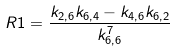<formula> <loc_0><loc_0><loc_500><loc_500>R 1 = \frac { k _ { 2 , 6 } k _ { 6 , 4 } - k _ { 4 , 6 } k _ { 6 , 2 } } { k _ { 6 , 6 } ^ { 7 } }</formula> 